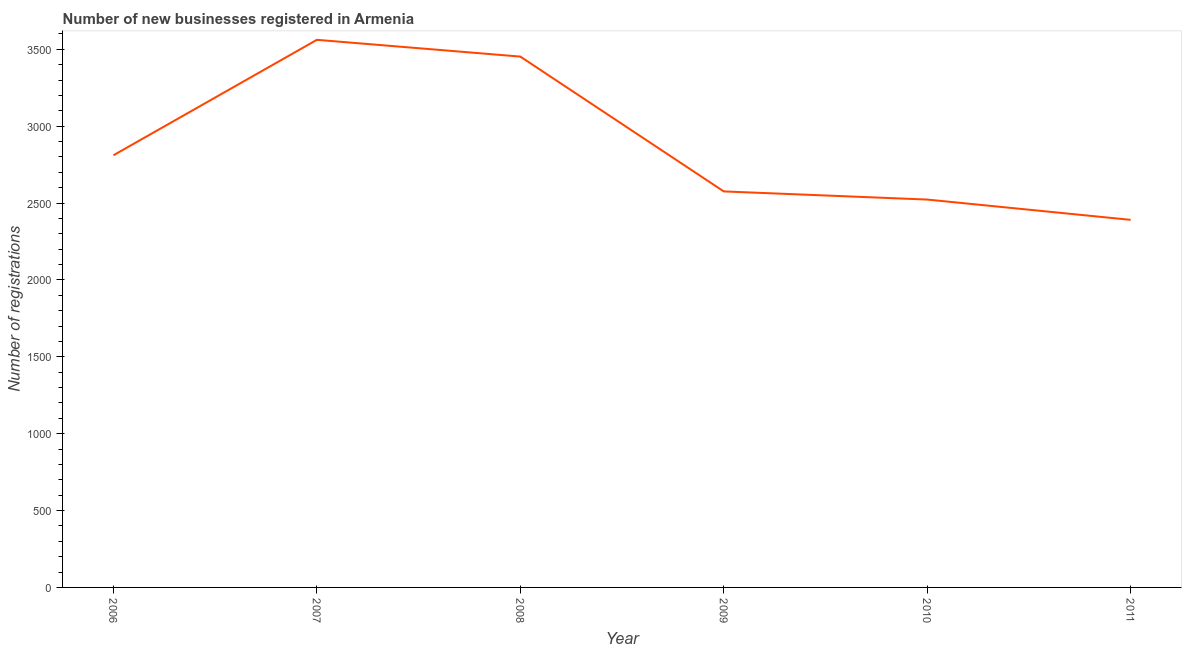What is the number of new business registrations in 2011?
Make the answer very short. 2391. Across all years, what is the maximum number of new business registrations?
Your answer should be compact. 3562. Across all years, what is the minimum number of new business registrations?
Ensure brevity in your answer.  2391. In which year was the number of new business registrations minimum?
Ensure brevity in your answer.  2011. What is the sum of the number of new business registrations?
Your response must be concise. 1.73e+04. What is the difference between the number of new business registrations in 2007 and 2011?
Keep it short and to the point. 1171. What is the average number of new business registrations per year?
Provide a succinct answer. 2886. What is the median number of new business registrations?
Provide a short and direct response. 2693.5. In how many years, is the number of new business registrations greater than 1600 ?
Provide a succinct answer. 6. What is the ratio of the number of new business registrations in 2010 to that in 2011?
Your answer should be very brief. 1.06. Is the number of new business registrations in 2007 less than that in 2009?
Your answer should be compact. No. Is the difference between the number of new business registrations in 2008 and 2010 greater than the difference between any two years?
Ensure brevity in your answer.  No. What is the difference between the highest and the second highest number of new business registrations?
Offer a very short reply. 109. What is the difference between the highest and the lowest number of new business registrations?
Ensure brevity in your answer.  1171. How many lines are there?
Provide a short and direct response. 1. Does the graph contain grids?
Your answer should be compact. No. What is the title of the graph?
Your answer should be compact. Number of new businesses registered in Armenia. What is the label or title of the Y-axis?
Ensure brevity in your answer.  Number of registrations. What is the Number of registrations of 2006?
Keep it short and to the point. 2811. What is the Number of registrations in 2007?
Offer a very short reply. 3562. What is the Number of registrations of 2008?
Make the answer very short. 3453. What is the Number of registrations of 2009?
Ensure brevity in your answer.  2576. What is the Number of registrations in 2010?
Your answer should be very brief. 2523. What is the Number of registrations of 2011?
Offer a terse response. 2391. What is the difference between the Number of registrations in 2006 and 2007?
Your answer should be very brief. -751. What is the difference between the Number of registrations in 2006 and 2008?
Your answer should be very brief. -642. What is the difference between the Number of registrations in 2006 and 2009?
Provide a short and direct response. 235. What is the difference between the Number of registrations in 2006 and 2010?
Keep it short and to the point. 288. What is the difference between the Number of registrations in 2006 and 2011?
Your answer should be compact. 420. What is the difference between the Number of registrations in 2007 and 2008?
Keep it short and to the point. 109. What is the difference between the Number of registrations in 2007 and 2009?
Your answer should be compact. 986. What is the difference between the Number of registrations in 2007 and 2010?
Provide a short and direct response. 1039. What is the difference between the Number of registrations in 2007 and 2011?
Keep it short and to the point. 1171. What is the difference between the Number of registrations in 2008 and 2009?
Your answer should be very brief. 877. What is the difference between the Number of registrations in 2008 and 2010?
Offer a terse response. 930. What is the difference between the Number of registrations in 2008 and 2011?
Provide a succinct answer. 1062. What is the difference between the Number of registrations in 2009 and 2010?
Your answer should be very brief. 53. What is the difference between the Number of registrations in 2009 and 2011?
Your answer should be very brief. 185. What is the difference between the Number of registrations in 2010 and 2011?
Your answer should be very brief. 132. What is the ratio of the Number of registrations in 2006 to that in 2007?
Provide a succinct answer. 0.79. What is the ratio of the Number of registrations in 2006 to that in 2008?
Your answer should be very brief. 0.81. What is the ratio of the Number of registrations in 2006 to that in 2009?
Your answer should be compact. 1.09. What is the ratio of the Number of registrations in 2006 to that in 2010?
Provide a short and direct response. 1.11. What is the ratio of the Number of registrations in 2006 to that in 2011?
Make the answer very short. 1.18. What is the ratio of the Number of registrations in 2007 to that in 2008?
Give a very brief answer. 1.03. What is the ratio of the Number of registrations in 2007 to that in 2009?
Your answer should be very brief. 1.38. What is the ratio of the Number of registrations in 2007 to that in 2010?
Give a very brief answer. 1.41. What is the ratio of the Number of registrations in 2007 to that in 2011?
Offer a very short reply. 1.49. What is the ratio of the Number of registrations in 2008 to that in 2009?
Your answer should be compact. 1.34. What is the ratio of the Number of registrations in 2008 to that in 2010?
Provide a succinct answer. 1.37. What is the ratio of the Number of registrations in 2008 to that in 2011?
Give a very brief answer. 1.44. What is the ratio of the Number of registrations in 2009 to that in 2011?
Give a very brief answer. 1.08. What is the ratio of the Number of registrations in 2010 to that in 2011?
Provide a succinct answer. 1.05. 